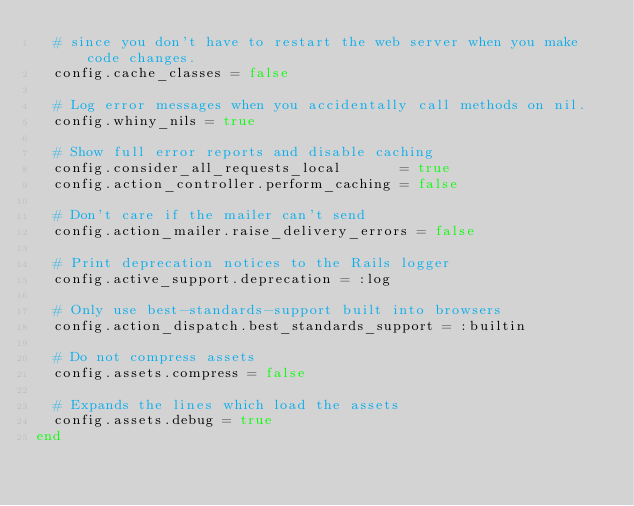Convert code to text. <code><loc_0><loc_0><loc_500><loc_500><_Ruby_>  # since you don't have to restart the web server when you make code changes.
  config.cache_classes = false

  # Log error messages when you accidentally call methods on nil.
  config.whiny_nils = true

  # Show full error reports and disable caching
  config.consider_all_requests_local       = true
  config.action_controller.perform_caching = false

  # Don't care if the mailer can't send
  config.action_mailer.raise_delivery_errors = false

  # Print deprecation notices to the Rails logger
  config.active_support.deprecation = :log

  # Only use best-standards-support built into browsers
  config.action_dispatch.best_standards_support = :builtin

  # Do not compress assets
  config.assets.compress = false

  # Expands the lines which load the assets
  config.assets.debug = true
end
</code> 